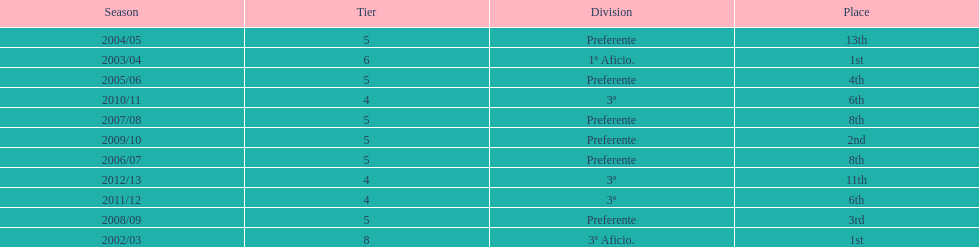Which section has the highest number of levels? Preferente. 